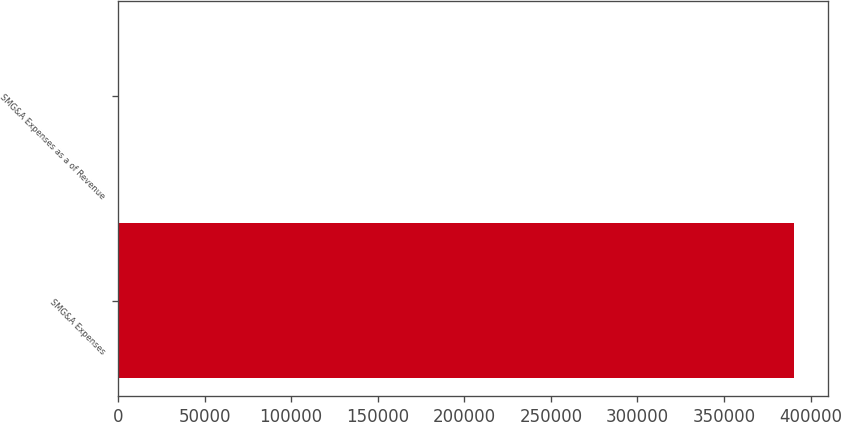Convert chart. <chart><loc_0><loc_0><loc_500><loc_500><bar_chart><fcel>SMG&A Expenses<fcel>SMG&A Expenses as a of Revenue<nl><fcel>390560<fcel>14.1<nl></chart> 